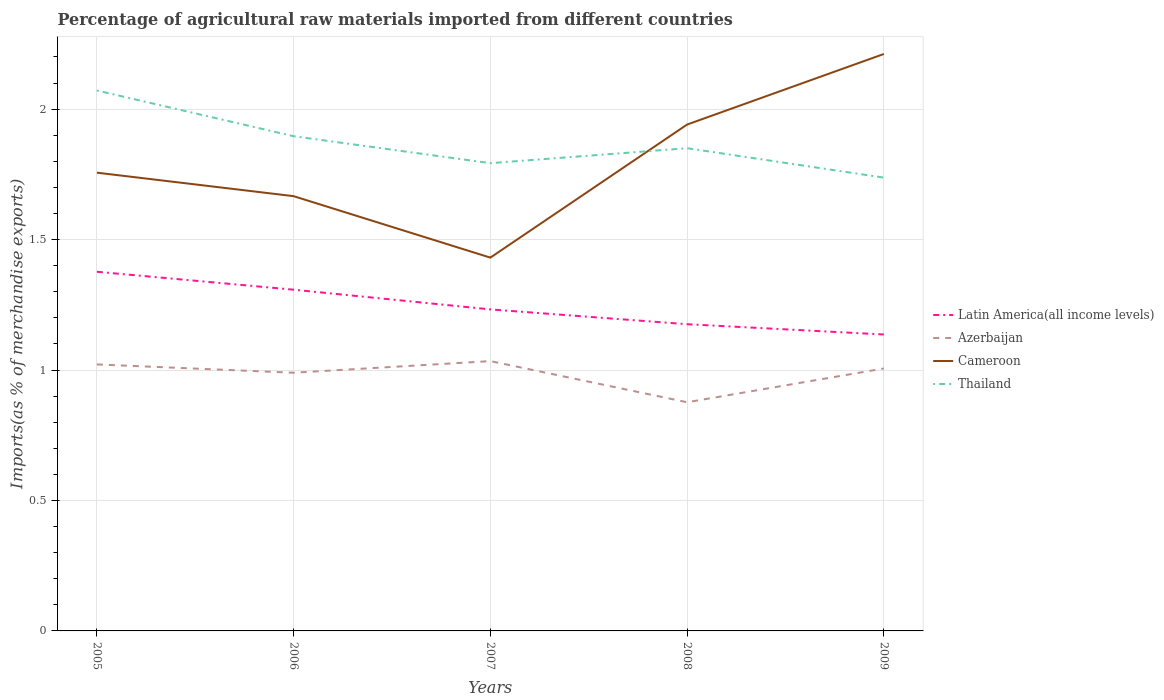How many different coloured lines are there?
Make the answer very short. 4. Does the line corresponding to Latin America(all income levels) intersect with the line corresponding to Azerbaijan?
Keep it short and to the point. No. Across all years, what is the maximum percentage of imports to different countries in Azerbaijan?
Give a very brief answer. 0.88. What is the total percentage of imports to different countries in Thailand in the graph?
Offer a very short reply. 0.06. What is the difference between the highest and the second highest percentage of imports to different countries in Cameroon?
Ensure brevity in your answer.  0.78. What is the difference between the highest and the lowest percentage of imports to different countries in Latin America(all income levels)?
Your answer should be compact. 2. Does the graph contain any zero values?
Your answer should be very brief. No. What is the title of the graph?
Give a very brief answer. Percentage of agricultural raw materials imported from different countries. What is the label or title of the X-axis?
Keep it short and to the point. Years. What is the label or title of the Y-axis?
Provide a succinct answer. Imports(as % of merchandise exports). What is the Imports(as % of merchandise exports) in Latin America(all income levels) in 2005?
Your response must be concise. 1.38. What is the Imports(as % of merchandise exports) in Azerbaijan in 2005?
Provide a short and direct response. 1.02. What is the Imports(as % of merchandise exports) of Cameroon in 2005?
Your answer should be compact. 1.76. What is the Imports(as % of merchandise exports) in Thailand in 2005?
Your answer should be compact. 2.07. What is the Imports(as % of merchandise exports) of Latin America(all income levels) in 2006?
Give a very brief answer. 1.31. What is the Imports(as % of merchandise exports) in Azerbaijan in 2006?
Ensure brevity in your answer.  0.99. What is the Imports(as % of merchandise exports) in Cameroon in 2006?
Keep it short and to the point. 1.67. What is the Imports(as % of merchandise exports) in Thailand in 2006?
Ensure brevity in your answer.  1.9. What is the Imports(as % of merchandise exports) in Latin America(all income levels) in 2007?
Ensure brevity in your answer.  1.23. What is the Imports(as % of merchandise exports) in Azerbaijan in 2007?
Provide a succinct answer. 1.03. What is the Imports(as % of merchandise exports) in Cameroon in 2007?
Keep it short and to the point. 1.43. What is the Imports(as % of merchandise exports) in Thailand in 2007?
Ensure brevity in your answer.  1.79. What is the Imports(as % of merchandise exports) of Latin America(all income levels) in 2008?
Give a very brief answer. 1.18. What is the Imports(as % of merchandise exports) in Azerbaijan in 2008?
Provide a succinct answer. 0.88. What is the Imports(as % of merchandise exports) in Cameroon in 2008?
Provide a short and direct response. 1.94. What is the Imports(as % of merchandise exports) of Thailand in 2008?
Provide a succinct answer. 1.85. What is the Imports(as % of merchandise exports) in Latin America(all income levels) in 2009?
Your answer should be compact. 1.14. What is the Imports(as % of merchandise exports) of Azerbaijan in 2009?
Your response must be concise. 1.01. What is the Imports(as % of merchandise exports) in Cameroon in 2009?
Your answer should be very brief. 2.21. What is the Imports(as % of merchandise exports) in Thailand in 2009?
Offer a very short reply. 1.74. Across all years, what is the maximum Imports(as % of merchandise exports) of Latin America(all income levels)?
Ensure brevity in your answer.  1.38. Across all years, what is the maximum Imports(as % of merchandise exports) of Azerbaijan?
Offer a very short reply. 1.03. Across all years, what is the maximum Imports(as % of merchandise exports) of Cameroon?
Keep it short and to the point. 2.21. Across all years, what is the maximum Imports(as % of merchandise exports) in Thailand?
Provide a short and direct response. 2.07. Across all years, what is the minimum Imports(as % of merchandise exports) of Latin America(all income levels)?
Your answer should be very brief. 1.14. Across all years, what is the minimum Imports(as % of merchandise exports) in Azerbaijan?
Make the answer very short. 0.88. Across all years, what is the minimum Imports(as % of merchandise exports) of Cameroon?
Make the answer very short. 1.43. Across all years, what is the minimum Imports(as % of merchandise exports) in Thailand?
Provide a short and direct response. 1.74. What is the total Imports(as % of merchandise exports) of Latin America(all income levels) in the graph?
Offer a very short reply. 6.23. What is the total Imports(as % of merchandise exports) of Azerbaijan in the graph?
Provide a succinct answer. 4.93. What is the total Imports(as % of merchandise exports) of Cameroon in the graph?
Provide a short and direct response. 9.01. What is the total Imports(as % of merchandise exports) of Thailand in the graph?
Give a very brief answer. 9.35. What is the difference between the Imports(as % of merchandise exports) of Latin America(all income levels) in 2005 and that in 2006?
Your answer should be very brief. 0.07. What is the difference between the Imports(as % of merchandise exports) in Azerbaijan in 2005 and that in 2006?
Offer a very short reply. 0.03. What is the difference between the Imports(as % of merchandise exports) in Cameroon in 2005 and that in 2006?
Your response must be concise. 0.09. What is the difference between the Imports(as % of merchandise exports) in Thailand in 2005 and that in 2006?
Offer a very short reply. 0.18. What is the difference between the Imports(as % of merchandise exports) of Latin America(all income levels) in 2005 and that in 2007?
Give a very brief answer. 0.14. What is the difference between the Imports(as % of merchandise exports) of Azerbaijan in 2005 and that in 2007?
Provide a short and direct response. -0.01. What is the difference between the Imports(as % of merchandise exports) of Cameroon in 2005 and that in 2007?
Provide a succinct answer. 0.33. What is the difference between the Imports(as % of merchandise exports) in Thailand in 2005 and that in 2007?
Offer a terse response. 0.28. What is the difference between the Imports(as % of merchandise exports) of Latin America(all income levels) in 2005 and that in 2008?
Your answer should be very brief. 0.2. What is the difference between the Imports(as % of merchandise exports) of Azerbaijan in 2005 and that in 2008?
Offer a terse response. 0.14. What is the difference between the Imports(as % of merchandise exports) of Cameroon in 2005 and that in 2008?
Give a very brief answer. -0.18. What is the difference between the Imports(as % of merchandise exports) in Thailand in 2005 and that in 2008?
Keep it short and to the point. 0.22. What is the difference between the Imports(as % of merchandise exports) in Latin America(all income levels) in 2005 and that in 2009?
Your response must be concise. 0.24. What is the difference between the Imports(as % of merchandise exports) in Azerbaijan in 2005 and that in 2009?
Keep it short and to the point. 0.02. What is the difference between the Imports(as % of merchandise exports) of Cameroon in 2005 and that in 2009?
Your response must be concise. -0.45. What is the difference between the Imports(as % of merchandise exports) in Thailand in 2005 and that in 2009?
Ensure brevity in your answer.  0.33. What is the difference between the Imports(as % of merchandise exports) of Latin America(all income levels) in 2006 and that in 2007?
Give a very brief answer. 0.08. What is the difference between the Imports(as % of merchandise exports) in Azerbaijan in 2006 and that in 2007?
Make the answer very short. -0.04. What is the difference between the Imports(as % of merchandise exports) in Cameroon in 2006 and that in 2007?
Keep it short and to the point. 0.24. What is the difference between the Imports(as % of merchandise exports) of Thailand in 2006 and that in 2007?
Your response must be concise. 0.1. What is the difference between the Imports(as % of merchandise exports) in Latin America(all income levels) in 2006 and that in 2008?
Your answer should be compact. 0.13. What is the difference between the Imports(as % of merchandise exports) in Azerbaijan in 2006 and that in 2008?
Your answer should be very brief. 0.11. What is the difference between the Imports(as % of merchandise exports) of Cameroon in 2006 and that in 2008?
Give a very brief answer. -0.27. What is the difference between the Imports(as % of merchandise exports) in Thailand in 2006 and that in 2008?
Offer a terse response. 0.05. What is the difference between the Imports(as % of merchandise exports) of Latin America(all income levels) in 2006 and that in 2009?
Offer a terse response. 0.17. What is the difference between the Imports(as % of merchandise exports) in Azerbaijan in 2006 and that in 2009?
Your answer should be compact. -0.02. What is the difference between the Imports(as % of merchandise exports) of Cameroon in 2006 and that in 2009?
Provide a short and direct response. -0.54. What is the difference between the Imports(as % of merchandise exports) of Thailand in 2006 and that in 2009?
Your response must be concise. 0.16. What is the difference between the Imports(as % of merchandise exports) in Latin America(all income levels) in 2007 and that in 2008?
Make the answer very short. 0.06. What is the difference between the Imports(as % of merchandise exports) of Azerbaijan in 2007 and that in 2008?
Keep it short and to the point. 0.16. What is the difference between the Imports(as % of merchandise exports) of Cameroon in 2007 and that in 2008?
Ensure brevity in your answer.  -0.51. What is the difference between the Imports(as % of merchandise exports) in Thailand in 2007 and that in 2008?
Provide a short and direct response. -0.06. What is the difference between the Imports(as % of merchandise exports) of Latin America(all income levels) in 2007 and that in 2009?
Give a very brief answer. 0.1. What is the difference between the Imports(as % of merchandise exports) of Azerbaijan in 2007 and that in 2009?
Your answer should be compact. 0.03. What is the difference between the Imports(as % of merchandise exports) in Cameroon in 2007 and that in 2009?
Provide a short and direct response. -0.78. What is the difference between the Imports(as % of merchandise exports) in Thailand in 2007 and that in 2009?
Ensure brevity in your answer.  0.06. What is the difference between the Imports(as % of merchandise exports) of Latin America(all income levels) in 2008 and that in 2009?
Offer a very short reply. 0.04. What is the difference between the Imports(as % of merchandise exports) of Azerbaijan in 2008 and that in 2009?
Offer a terse response. -0.13. What is the difference between the Imports(as % of merchandise exports) of Cameroon in 2008 and that in 2009?
Provide a short and direct response. -0.27. What is the difference between the Imports(as % of merchandise exports) of Thailand in 2008 and that in 2009?
Your answer should be compact. 0.11. What is the difference between the Imports(as % of merchandise exports) in Latin America(all income levels) in 2005 and the Imports(as % of merchandise exports) in Azerbaijan in 2006?
Provide a short and direct response. 0.39. What is the difference between the Imports(as % of merchandise exports) of Latin America(all income levels) in 2005 and the Imports(as % of merchandise exports) of Cameroon in 2006?
Keep it short and to the point. -0.29. What is the difference between the Imports(as % of merchandise exports) in Latin America(all income levels) in 2005 and the Imports(as % of merchandise exports) in Thailand in 2006?
Ensure brevity in your answer.  -0.52. What is the difference between the Imports(as % of merchandise exports) in Azerbaijan in 2005 and the Imports(as % of merchandise exports) in Cameroon in 2006?
Provide a succinct answer. -0.64. What is the difference between the Imports(as % of merchandise exports) of Azerbaijan in 2005 and the Imports(as % of merchandise exports) of Thailand in 2006?
Provide a short and direct response. -0.87. What is the difference between the Imports(as % of merchandise exports) of Cameroon in 2005 and the Imports(as % of merchandise exports) of Thailand in 2006?
Offer a terse response. -0.14. What is the difference between the Imports(as % of merchandise exports) of Latin America(all income levels) in 2005 and the Imports(as % of merchandise exports) of Azerbaijan in 2007?
Give a very brief answer. 0.34. What is the difference between the Imports(as % of merchandise exports) of Latin America(all income levels) in 2005 and the Imports(as % of merchandise exports) of Cameroon in 2007?
Make the answer very short. -0.05. What is the difference between the Imports(as % of merchandise exports) of Latin America(all income levels) in 2005 and the Imports(as % of merchandise exports) of Thailand in 2007?
Make the answer very short. -0.42. What is the difference between the Imports(as % of merchandise exports) in Azerbaijan in 2005 and the Imports(as % of merchandise exports) in Cameroon in 2007?
Give a very brief answer. -0.41. What is the difference between the Imports(as % of merchandise exports) of Azerbaijan in 2005 and the Imports(as % of merchandise exports) of Thailand in 2007?
Ensure brevity in your answer.  -0.77. What is the difference between the Imports(as % of merchandise exports) in Cameroon in 2005 and the Imports(as % of merchandise exports) in Thailand in 2007?
Provide a short and direct response. -0.04. What is the difference between the Imports(as % of merchandise exports) in Latin America(all income levels) in 2005 and the Imports(as % of merchandise exports) in Azerbaijan in 2008?
Ensure brevity in your answer.  0.5. What is the difference between the Imports(as % of merchandise exports) of Latin America(all income levels) in 2005 and the Imports(as % of merchandise exports) of Cameroon in 2008?
Give a very brief answer. -0.56. What is the difference between the Imports(as % of merchandise exports) in Latin America(all income levels) in 2005 and the Imports(as % of merchandise exports) in Thailand in 2008?
Ensure brevity in your answer.  -0.47. What is the difference between the Imports(as % of merchandise exports) in Azerbaijan in 2005 and the Imports(as % of merchandise exports) in Cameroon in 2008?
Your answer should be very brief. -0.92. What is the difference between the Imports(as % of merchandise exports) in Azerbaijan in 2005 and the Imports(as % of merchandise exports) in Thailand in 2008?
Give a very brief answer. -0.83. What is the difference between the Imports(as % of merchandise exports) of Cameroon in 2005 and the Imports(as % of merchandise exports) of Thailand in 2008?
Your answer should be very brief. -0.09. What is the difference between the Imports(as % of merchandise exports) in Latin America(all income levels) in 2005 and the Imports(as % of merchandise exports) in Azerbaijan in 2009?
Offer a very short reply. 0.37. What is the difference between the Imports(as % of merchandise exports) of Latin America(all income levels) in 2005 and the Imports(as % of merchandise exports) of Cameroon in 2009?
Your answer should be compact. -0.83. What is the difference between the Imports(as % of merchandise exports) in Latin America(all income levels) in 2005 and the Imports(as % of merchandise exports) in Thailand in 2009?
Offer a very short reply. -0.36. What is the difference between the Imports(as % of merchandise exports) in Azerbaijan in 2005 and the Imports(as % of merchandise exports) in Cameroon in 2009?
Make the answer very short. -1.19. What is the difference between the Imports(as % of merchandise exports) of Azerbaijan in 2005 and the Imports(as % of merchandise exports) of Thailand in 2009?
Make the answer very short. -0.72. What is the difference between the Imports(as % of merchandise exports) in Cameroon in 2005 and the Imports(as % of merchandise exports) in Thailand in 2009?
Your response must be concise. 0.02. What is the difference between the Imports(as % of merchandise exports) of Latin America(all income levels) in 2006 and the Imports(as % of merchandise exports) of Azerbaijan in 2007?
Your answer should be compact. 0.27. What is the difference between the Imports(as % of merchandise exports) in Latin America(all income levels) in 2006 and the Imports(as % of merchandise exports) in Cameroon in 2007?
Provide a succinct answer. -0.12. What is the difference between the Imports(as % of merchandise exports) in Latin America(all income levels) in 2006 and the Imports(as % of merchandise exports) in Thailand in 2007?
Make the answer very short. -0.48. What is the difference between the Imports(as % of merchandise exports) in Azerbaijan in 2006 and the Imports(as % of merchandise exports) in Cameroon in 2007?
Provide a short and direct response. -0.44. What is the difference between the Imports(as % of merchandise exports) in Azerbaijan in 2006 and the Imports(as % of merchandise exports) in Thailand in 2007?
Provide a succinct answer. -0.8. What is the difference between the Imports(as % of merchandise exports) in Cameroon in 2006 and the Imports(as % of merchandise exports) in Thailand in 2007?
Make the answer very short. -0.13. What is the difference between the Imports(as % of merchandise exports) of Latin America(all income levels) in 2006 and the Imports(as % of merchandise exports) of Azerbaijan in 2008?
Keep it short and to the point. 0.43. What is the difference between the Imports(as % of merchandise exports) of Latin America(all income levels) in 2006 and the Imports(as % of merchandise exports) of Cameroon in 2008?
Your answer should be very brief. -0.63. What is the difference between the Imports(as % of merchandise exports) in Latin America(all income levels) in 2006 and the Imports(as % of merchandise exports) in Thailand in 2008?
Ensure brevity in your answer.  -0.54. What is the difference between the Imports(as % of merchandise exports) of Azerbaijan in 2006 and the Imports(as % of merchandise exports) of Cameroon in 2008?
Your answer should be very brief. -0.95. What is the difference between the Imports(as % of merchandise exports) in Azerbaijan in 2006 and the Imports(as % of merchandise exports) in Thailand in 2008?
Your answer should be compact. -0.86. What is the difference between the Imports(as % of merchandise exports) of Cameroon in 2006 and the Imports(as % of merchandise exports) of Thailand in 2008?
Offer a very short reply. -0.18. What is the difference between the Imports(as % of merchandise exports) of Latin America(all income levels) in 2006 and the Imports(as % of merchandise exports) of Azerbaijan in 2009?
Your response must be concise. 0.3. What is the difference between the Imports(as % of merchandise exports) in Latin America(all income levels) in 2006 and the Imports(as % of merchandise exports) in Cameroon in 2009?
Your answer should be very brief. -0.9. What is the difference between the Imports(as % of merchandise exports) of Latin America(all income levels) in 2006 and the Imports(as % of merchandise exports) of Thailand in 2009?
Your answer should be very brief. -0.43. What is the difference between the Imports(as % of merchandise exports) in Azerbaijan in 2006 and the Imports(as % of merchandise exports) in Cameroon in 2009?
Ensure brevity in your answer.  -1.22. What is the difference between the Imports(as % of merchandise exports) of Azerbaijan in 2006 and the Imports(as % of merchandise exports) of Thailand in 2009?
Provide a succinct answer. -0.75. What is the difference between the Imports(as % of merchandise exports) in Cameroon in 2006 and the Imports(as % of merchandise exports) in Thailand in 2009?
Offer a very short reply. -0.07. What is the difference between the Imports(as % of merchandise exports) of Latin America(all income levels) in 2007 and the Imports(as % of merchandise exports) of Azerbaijan in 2008?
Make the answer very short. 0.36. What is the difference between the Imports(as % of merchandise exports) of Latin America(all income levels) in 2007 and the Imports(as % of merchandise exports) of Cameroon in 2008?
Make the answer very short. -0.71. What is the difference between the Imports(as % of merchandise exports) in Latin America(all income levels) in 2007 and the Imports(as % of merchandise exports) in Thailand in 2008?
Give a very brief answer. -0.62. What is the difference between the Imports(as % of merchandise exports) in Azerbaijan in 2007 and the Imports(as % of merchandise exports) in Cameroon in 2008?
Provide a short and direct response. -0.91. What is the difference between the Imports(as % of merchandise exports) of Azerbaijan in 2007 and the Imports(as % of merchandise exports) of Thailand in 2008?
Offer a terse response. -0.82. What is the difference between the Imports(as % of merchandise exports) in Cameroon in 2007 and the Imports(as % of merchandise exports) in Thailand in 2008?
Your answer should be very brief. -0.42. What is the difference between the Imports(as % of merchandise exports) of Latin America(all income levels) in 2007 and the Imports(as % of merchandise exports) of Azerbaijan in 2009?
Offer a terse response. 0.23. What is the difference between the Imports(as % of merchandise exports) of Latin America(all income levels) in 2007 and the Imports(as % of merchandise exports) of Cameroon in 2009?
Keep it short and to the point. -0.98. What is the difference between the Imports(as % of merchandise exports) of Latin America(all income levels) in 2007 and the Imports(as % of merchandise exports) of Thailand in 2009?
Ensure brevity in your answer.  -0.51. What is the difference between the Imports(as % of merchandise exports) of Azerbaijan in 2007 and the Imports(as % of merchandise exports) of Cameroon in 2009?
Keep it short and to the point. -1.18. What is the difference between the Imports(as % of merchandise exports) of Azerbaijan in 2007 and the Imports(as % of merchandise exports) of Thailand in 2009?
Offer a terse response. -0.7. What is the difference between the Imports(as % of merchandise exports) in Cameroon in 2007 and the Imports(as % of merchandise exports) in Thailand in 2009?
Provide a succinct answer. -0.31. What is the difference between the Imports(as % of merchandise exports) of Latin America(all income levels) in 2008 and the Imports(as % of merchandise exports) of Azerbaijan in 2009?
Keep it short and to the point. 0.17. What is the difference between the Imports(as % of merchandise exports) of Latin America(all income levels) in 2008 and the Imports(as % of merchandise exports) of Cameroon in 2009?
Your answer should be very brief. -1.04. What is the difference between the Imports(as % of merchandise exports) in Latin America(all income levels) in 2008 and the Imports(as % of merchandise exports) in Thailand in 2009?
Give a very brief answer. -0.56. What is the difference between the Imports(as % of merchandise exports) of Azerbaijan in 2008 and the Imports(as % of merchandise exports) of Cameroon in 2009?
Provide a short and direct response. -1.33. What is the difference between the Imports(as % of merchandise exports) in Azerbaijan in 2008 and the Imports(as % of merchandise exports) in Thailand in 2009?
Provide a succinct answer. -0.86. What is the difference between the Imports(as % of merchandise exports) of Cameroon in 2008 and the Imports(as % of merchandise exports) of Thailand in 2009?
Keep it short and to the point. 0.2. What is the average Imports(as % of merchandise exports) in Latin America(all income levels) per year?
Make the answer very short. 1.25. What is the average Imports(as % of merchandise exports) of Azerbaijan per year?
Make the answer very short. 0.99. What is the average Imports(as % of merchandise exports) of Cameroon per year?
Ensure brevity in your answer.  1.8. What is the average Imports(as % of merchandise exports) of Thailand per year?
Your answer should be very brief. 1.87. In the year 2005, what is the difference between the Imports(as % of merchandise exports) of Latin America(all income levels) and Imports(as % of merchandise exports) of Azerbaijan?
Your answer should be very brief. 0.36. In the year 2005, what is the difference between the Imports(as % of merchandise exports) of Latin America(all income levels) and Imports(as % of merchandise exports) of Cameroon?
Your response must be concise. -0.38. In the year 2005, what is the difference between the Imports(as % of merchandise exports) in Latin America(all income levels) and Imports(as % of merchandise exports) in Thailand?
Give a very brief answer. -0.69. In the year 2005, what is the difference between the Imports(as % of merchandise exports) in Azerbaijan and Imports(as % of merchandise exports) in Cameroon?
Offer a very short reply. -0.73. In the year 2005, what is the difference between the Imports(as % of merchandise exports) of Azerbaijan and Imports(as % of merchandise exports) of Thailand?
Offer a very short reply. -1.05. In the year 2005, what is the difference between the Imports(as % of merchandise exports) in Cameroon and Imports(as % of merchandise exports) in Thailand?
Keep it short and to the point. -0.31. In the year 2006, what is the difference between the Imports(as % of merchandise exports) in Latin America(all income levels) and Imports(as % of merchandise exports) in Azerbaijan?
Give a very brief answer. 0.32. In the year 2006, what is the difference between the Imports(as % of merchandise exports) of Latin America(all income levels) and Imports(as % of merchandise exports) of Cameroon?
Make the answer very short. -0.36. In the year 2006, what is the difference between the Imports(as % of merchandise exports) of Latin America(all income levels) and Imports(as % of merchandise exports) of Thailand?
Provide a short and direct response. -0.59. In the year 2006, what is the difference between the Imports(as % of merchandise exports) in Azerbaijan and Imports(as % of merchandise exports) in Cameroon?
Your response must be concise. -0.68. In the year 2006, what is the difference between the Imports(as % of merchandise exports) of Azerbaijan and Imports(as % of merchandise exports) of Thailand?
Your response must be concise. -0.91. In the year 2006, what is the difference between the Imports(as % of merchandise exports) of Cameroon and Imports(as % of merchandise exports) of Thailand?
Give a very brief answer. -0.23. In the year 2007, what is the difference between the Imports(as % of merchandise exports) in Latin America(all income levels) and Imports(as % of merchandise exports) in Azerbaijan?
Your response must be concise. 0.2. In the year 2007, what is the difference between the Imports(as % of merchandise exports) of Latin America(all income levels) and Imports(as % of merchandise exports) of Cameroon?
Provide a succinct answer. -0.2. In the year 2007, what is the difference between the Imports(as % of merchandise exports) of Latin America(all income levels) and Imports(as % of merchandise exports) of Thailand?
Your answer should be very brief. -0.56. In the year 2007, what is the difference between the Imports(as % of merchandise exports) of Azerbaijan and Imports(as % of merchandise exports) of Cameroon?
Offer a very short reply. -0.4. In the year 2007, what is the difference between the Imports(as % of merchandise exports) of Azerbaijan and Imports(as % of merchandise exports) of Thailand?
Offer a terse response. -0.76. In the year 2007, what is the difference between the Imports(as % of merchandise exports) in Cameroon and Imports(as % of merchandise exports) in Thailand?
Provide a succinct answer. -0.36. In the year 2008, what is the difference between the Imports(as % of merchandise exports) of Latin America(all income levels) and Imports(as % of merchandise exports) of Azerbaijan?
Your answer should be very brief. 0.3. In the year 2008, what is the difference between the Imports(as % of merchandise exports) in Latin America(all income levels) and Imports(as % of merchandise exports) in Cameroon?
Make the answer very short. -0.77. In the year 2008, what is the difference between the Imports(as % of merchandise exports) of Latin America(all income levels) and Imports(as % of merchandise exports) of Thailand?
Make the answer very short. -0.67. In the year 2008, what is the difference between the Imports(as % of merchandise exports) of Azerbaijan and Imports(as % of merchandise exports) of Cameroon?
Offer a very short reply. -1.06. In the year 2008, what is the difference between the Imports(as % of merchandise exports) of Azerbaijan and Imports(as % of merchandise exports) of Thailand?
Keep it short and to the point. -0.97. In the year 2008, what is the difference between the Imports(as % of merchandise exports) in Cameroon and Imports(as % of merchandise exports) in Thailand?
Make the answer very short. 0.09. In the year 2009, what is the difference between the Imports(as % of merchandise exports) of Latin America(all income levels) and Imports(as % of merchandise exports) of Azerbaijan?
Give a very brief answer. 0.13. In the year 2009, what is the difference between the Imports(as % of merchandise exports) in Latin America(all income levels) and Imports(as % of merchandise exports) in Cameroon?
Offer a terse response. -1.07. In the year 2009, what is the difference between the Imports(as % of merchandise exports) of Latin America(all income levels) and Imports(as % of merchandise exports) of Thailand?
Your response must be concise. -0.6. In the year 2009, what is the difference between the Imports(as % of merchandise exports) in Azerbaijan and Imports(as % of merchandise exports) in Cameroon?
Your response must be concise. -1.21. In the year 2009, what is the difference between the Imports(as % of merchandise exports) of Azerbaijan and Imports(as % of merchandise exports) of Thailand?
Your answer should be compact. -0.73. In the year 2009, what is the difference between the Imports(as % of merchandise exports) of Cameroon and Imports(as % of merchandise exports) of Thailand?
Your response must be concise. 0.47. What is the ratio of the Imports(as % of merchandise exports) in Latin America(all income levels) in 2005 to that in 2006?
Offer a terse response. 1.05. What is the ratio of the Imports(as % of merchandise exports) of Azerbaijan in 2005 to that in 2006?
Ensure brevity in your answer.  1.03. What is the ratio of the Imports(as % of merchandise exports) of Cameroon in 2005 to that in 2006?
Offer a very short reply. 1.05. What is the ratio of the Imports(as % of merchandise exports) in Thailand in 2005 to that in 2006?
Ensure brevity in your answer.  1.09. What is the ratio of the Imports(as % of merchandise exports) of Latin America(all income levels) in 2005 to that in 2007?
Provide a succinct answer. 1.12. What is the ratio of the Imports(as % of merchandise exports) in Azerbaijan in 2005 to that in 2007?
Make the answer very short. 0.99. What is the ratio of the Imports(as % of merchandise exports) in Cameroon in 2005 to that in 2007?
Give a very brief answer. 1.23. What is the ratio of the Imports(as % of merchandise exports) in Thailand in 2005 to that in 2007?
Provide a short and direct response. 1.16. What is the ratio of the Imports(as % of merchandise exports) in Latin America(all income levels) in 2005 to that in 2008?
Keep it short and to the point. 1.17. What is the ratio of the Imports(as % of merchandise exports) of Azerbaijan in 2005 to that in 2008?
Offer a very short reply. 1.17. What is the ratio of the Imports(as % of merchandise exports) of Cameroon in 2005 to that in 2008?
Keep it short and to the point. 0.91. What is the ratio of the Imports(as % of merchandise exports) of Thailand in 2005 to that in 2008?
Offer a very short reply. 1.12. What is the ratio of the Imports(as % of merchandise exports) of Latin America(all income levels) in 2005 to that in 2009?
Your response must be concise. 1.21. What is the ratio of the Imports(as % of merchandise exports) of Azerbaijan in 2005 to that in 2009?
Offer a very short reply. 1.02. What is the ratio of the Imports(as % of merchandise exports) of Cameroon in 2005 to that in 2009?
Your answer should be very brief. 0.79. What is the ratio of the Imports(as % of merchandise exports) of Thailand in 2005 to that in 2009?
Your response must be concise. 1.19. What is the ratio of the Imports(as % of merchandise exports) in Latin America(all income levels) in 2006 to that in 2007?
Provide a succinct answer. 1.06. What is the ratio of the Imports(as % of merchandise exports) in Azerbaijan in 2006 to that in 2007?
Offer a very short reply. 0.96. What is the ratio of the Imports(as % of merchandise exports) of Cameroon in 2006 to that in 2007?
Make the answer very short. 1.16. What is the ratio of the Imports(as % of merchandise exports) in Thailand in 2006 to that in 2007?
Provide a short and direct response. 1.06. What is the ratio of the Imports(as % of merchandise exports) of Latin America(all income levels) in 2006 to that in 2008?
Offer a terse response. 1.11. What is the ratio of the Imports(as % of merchandise exports) in Azerbaijan in 2006 to that in 2008?
Your response must be concise. 1.13. What is the ratio of the Imports(as % of merchandise exports) in Cameroon in 2006 to that in 2008?
Your response must be concise. 0.86. What is the ratio of the Imports(as % of merchandise exports) of Thailand in 2006 to that in 2008?
Ensure brevity in your answer.  1.02. What is the ratio of the Imports(as % of merchandise exports) in Latin America(all income levels) in 2006 to that in 2009?
Keep it short and to the point. 1.15. What is the ratio of the Imports(as % of merchandise exports) of Azerbaijan in 2006 to that in 2009?
Your response must be concise. 0.98. What is the ratio of the Imports(as % of merchandise exports) in Cameroon in 2006 to that in 2009?
Your response must be concise. 0.75. What is the ratio of the Imports(as % of merchandise exports) in Thailand in 2006 to that in 2009?
Your response must be concise. 1.09. What is the ratio of the Imports(as % of merchandise exports) in Latin America(all income levels) in 2007 to that in 2008?
Offer a terse response. 1.05. What is the ratio of the Imports(as % of merchandise exports) of Azerbaijan in 2007 to that in 2008?
Offer a very short reply. 1.18. What is the ratio of the Imports(as % of merchandise exports) of Cameroon in 2007 to that in 2008?
Keep it short and to the point. 0.74. What is the ratio of the Imports(as % of merchandise exports) in Thailand in 2007 to that in 2008?
Keep it short and to the point. 0.97. What is the ratio of the Imports(as % of merchandise exports) in Latin America(all income levels) in 2007 to that in 2009?
Offer a terse response. 1.08. What is the ratio of the Imports(as % of merchandise exports) in Azerbaijan in 2007 to that in 2009?
Offer a terse response. 1.03. What is the ratio of the Imports(as % of merchandise exports) of Cameroon in 2007 to that in 2009?
Keep it short and to the point. 0.65. What is the ratio of the Imports(as % of merchandise exports) of Thailand in 2007 to that in 2009?
Ensure brevity in your answer.  1.03. What is the ratio of the Imports(as % of merchandise exports) in Latin America(all income levels) in 2008 to that in 2009?
Your answer should be very brief. 1.03. What is the ratio of the Imports(as % of merchandise exports) in Azerbaijan in 2008 to that in 2009?
Give a very brief answer. 0.87. What is the ratio of the Imports(as % of merchandise exports) of Cameroon in 2008 to that in 2009?
Your answer should be compact. 0.88. What is the ratio of the Imports(as % of merchandise exports) in Thailand in 2008 to that in 2009?
Keep it short and to the point. 1.06. What is the difference between the highest and the second highest Imports(as % of merchandise exports) of Latin America(all income levels)?
Your answer should be compact. 0.07. What is the difference between the highest and the second highest Imports(as % of merchandise exports) in Azerbaijan?
Your answer should be very brief. 0.01. What is the difference between the highest and the second highest Imports(as % of merchandise exports) of Cameroon?
Ensure brevity in your answer.  0.27. What is the difference between the highest and the second highest Imports(as % of merchandise exports) in Thailand?
Give a very brief answer. 0.18. What is the difference between the highest and the lowest Imports(as % of merchandise exports) of Latin America(all income levels)?
Offer a very short reply. 0.24. What is the difference between the highest and the lowest Imports(as % of merchandise exports) in Azerbaijan?
Your answer should be very brief. 0.16. What is the difference between the highest and the lowest Imports(as % of merchandise exports) in Cameroon?
Your response must be concise. 0.78. What is the difference between the highest and the lowest Imports(as % of merchandise exports) in Thailand?
Give a very brief answer. 0.33. 